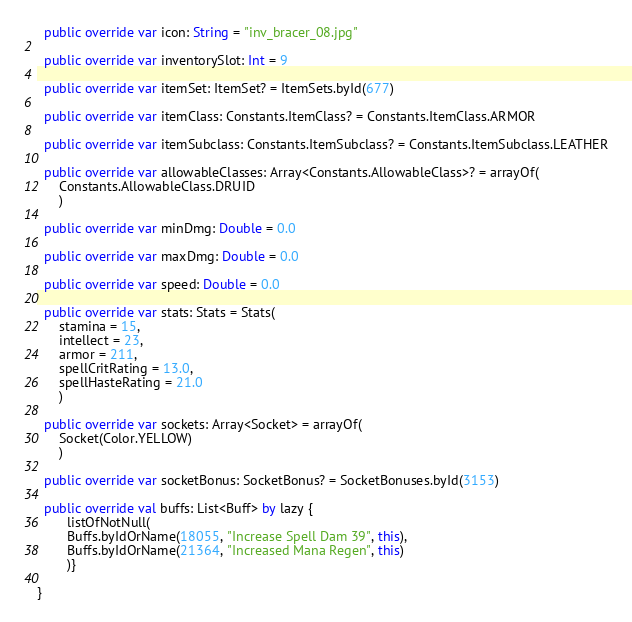Convert code to text. <code><loc_0><loc_0><loc_500><loc_500><_Kotlin_>
  public override var icon: String = "inv_bracer_08.jpg"

  public override var inventorySlot: Int = 9

  public override var itemSet: ItemSet? = ItemSets.byId(677)

  public override var itemClass: Constants.ItemClass? = Constants.ItemClass.ARMOR

  public override var itemSubclass: Constants.ItemSubclass? = Constants.ItemSubclass.LEATHER

  public override var allowableClasses: Array<Constants.AllowableClass>? = arrayOf(
      Constants.AllowableClass.DRUID
      )

  public override var minDmg: Double = 0.0

  public override var maxDmg: Double = 0.0

  public override var speed: Double = 0.0

  public override var stats: Stats = Stats(
      stamina = 15,
      intellect = 23,
      armor = 211,
      spellCritRating = 13.0,
      spellHasteRating = 21.0
      )

  public override var sockets: Array<Socket> = arrayOf(
      Socket(Color.YELLOW)
      )

  public override var socketBonus: SocketBonus? = SocketBonuses.byId(3153)

  public override val buffs: List<Buff> by lazy {
        listOfNotNull(
        Buffs.byIdOrName(18055, "Increase Spell Dam 39", this),
        Buffs.byIdOrName(21364, "Increased Mana Regen", this)
        )}

}
</code> 